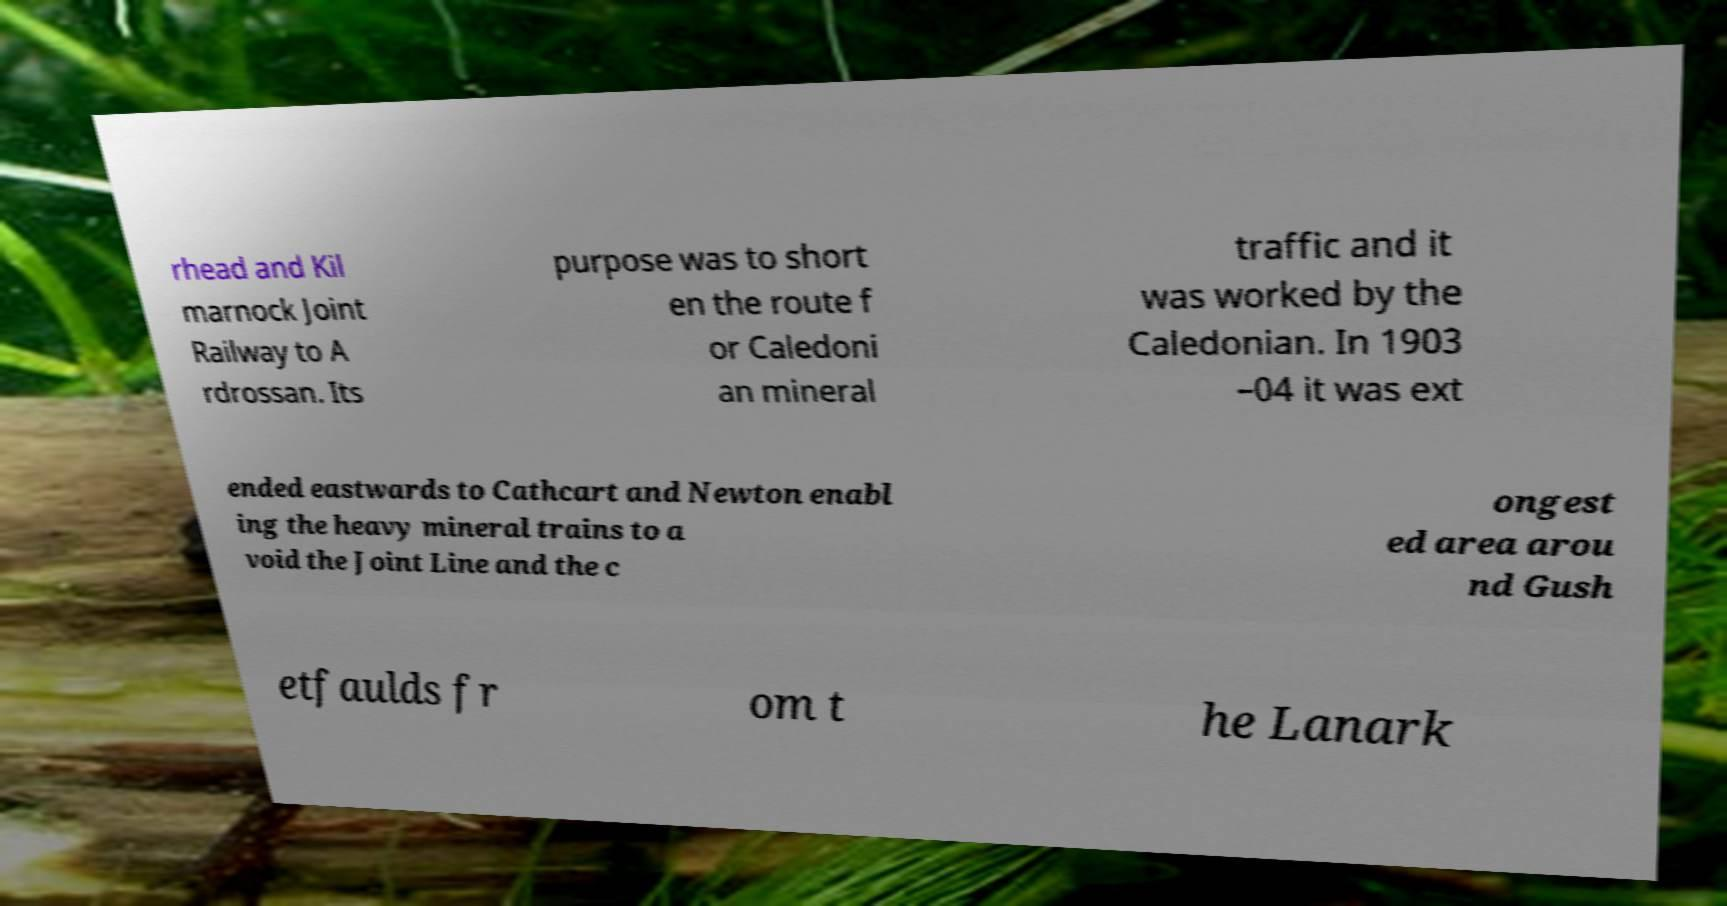Please identify and transcribe the text found in this image. rhead and Kil marnock Joint Railway to A rdrossan. Its purpose was to short en the route f or Caledoni an mineral traffic and it was worked by the Caledonian. In 1903 –04 it was ext ended eastwards to Cathcart and Newton enabl ing the heavy mineral trains to a void the Joint Line and the c ongest ed area arou nd Gush etfaulds fr om t he Lanark 